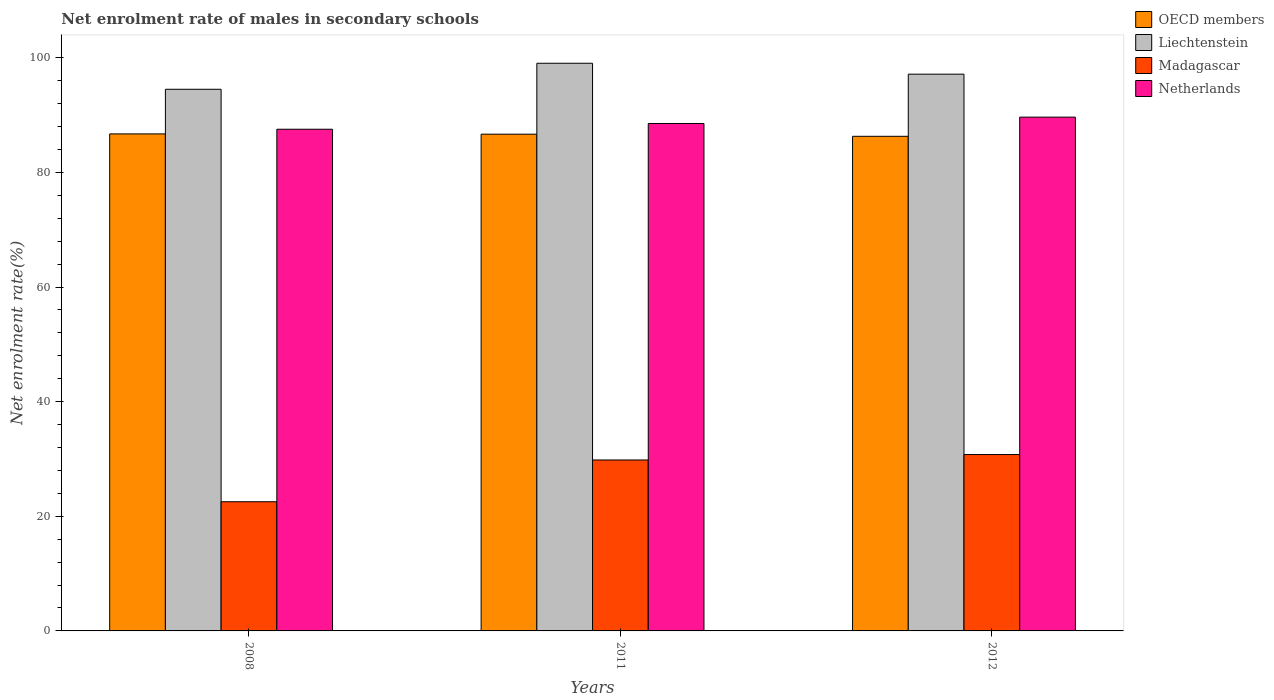How many different coloured bars are there?
Your answer should be very brief. 4. How many groups of bars are there?
Your answer should be very brief. 3. Are the number of bars per tick equal to the number of legend labels?
Provide a short and direct response. Yes. How many bars are there on the 3rd tick from the left?
Offer a terse response. 4. What is the label of the 2nd group of bars from the left?
Offer a terse response. 2011. What is the net enrolment rate of males in secondary schools in Liechtenstein in 2011?
Provide a succinct answer. 99.04. Across all years, what is the maximum net enrolment rate of males in secondary schools in OECD members?
Provide a succinct answer. 86.72. Across all years, what is the minimum net enrolment rate of males in secondary schools in Netherlands?
Provide a short and direct response. 87.53. In which year was the net enrolment rate of males in secondary schools in Netherlands minimum?
Provide a succinct answer. 2008. What is the total net enrolment rate of males in secondary schools in Netherlands in the graph?
Make the answer very short. 265.7. What is the difference between the net enrolment rate of males in secondary schools in OECD members in 2008 and that in 2011?
Make the answer very short. 0.05. What is the difference between the net enrolment rate of males in secondary schools in Liechtenstein in 2008 and the net enrolment rate of males in secondary schools in OECD members in 2012?
Offer a very short reply. 8.21. What is the average net enrolment rate of males in secondary schools in Netherlands per year?
Keep it short and to the point. 88.57. In the year 2011, what is the difference between the net enrolment rate of males in secondary schools in Netherlands and net enrolment rate of males in secondary schools in OECD members?
Provide a succinct answer. 1.86. What is the ratio of the net enrolment rate of males in secondary schools in Liechtenstein in 2011 to that in 2012?
Keep it short and to the point. 1.02. Is the net enrolment rate of males in secondary schools in Madagascar in 2011 less than that in 2012?
Offer a very short reply. Yes. What is the difference between the highest and the second highest net enrolment rate of males in secondary schools in OECD members?
Your response must be concise. 0.05. What is the difference between the highest and the lowest net enrolment rate of males in secondary schools in Liechtenstein?
Provide a short and direct response. 4.54. What does the 3rd bar from the left in 2011 represents?
Offer a terse response. Madagascar. What does the 2nd bar from the right in 2011 represents?
Your answer should be compact. Madagascar. How many bars are there?
Your answer should be very brief. 12. Are all the bars in the graph horizontal?
Offer a very short reply. No. What is the difference between two consecutive major ticks on the Y-axis?
Make the answer very short. 20. Where does the legend appear in the graph?
Keep it short and to the point. Top right. How are the legend labels stacked?
Offer a terse response. Vertical. What is the title of the graph?
Give a very brief answer. Net enrolment rate of males in secondary schools. What is the label or title of the X-axis?
Your answer should be compact. Years. What is the label or title of the Y-axis?
Your answer should be very brief. Net enrolment rate(%). What is the Net enrolment rate(%) in OECD members in 2008?
Ensure brevity in your answer.  86.72. What is the Net enrolment rate(%) of Liechtenstein in 2008?
Provide a succinct answer. 94.5. What is the Net enrolment rate(%) of Madagascar in 2008?
Ensure brevity in your answer.  22.54. What is the Net enrolment rate(%) of Netherlands in 2008?
Give a very brief answer. 87.53. What is the Net enrolment rate(%) of OECD members in 2011?
Give a very brief answer. 86.67. What is the Net enrolment rate(%) in Liechtenstein in 2011?
Make the answer very short. 99.04. What is the Net enrolment rate(%) in Madagascar in 2011?
Your response must be concise. 29.83. What is the Net enrolment rate(%) in Netherlands in 2011?
Make the answer very short. 88.53. What is the Net enrolment rate(%) of OECD members in 2012?
Offer a terse response. 86.3. What is the Net enrolment rate(%) in Liechtenstein in 2012?
Your answer should be compact. 97.14. What is the Net enrolment rate(%) in Madagascar in 2012?
Make the answer very short. 30.78. What is the Net enrolment rate(%) of Netherlands in 2012?
Keep it short and to the point. 89.64. Across all years, what is the maximum Net enrolment rate(%) of OECD members?
Ensure brevity in your answer.  86.72. Across all years, what is the maximum Net enrolment rate(%) in Liechtenstein?
Your answer should be very brief. 99.04. Across all years, what is the maximum Net enrolment rate(%) in Madagascar?
Your answer should be compact. 30.78. Across all years, what is the maximum Net enrolment rate(%) of Netherlands?
Your answer should be very brief. 89.64. Across all years, what is the minimum Net enrolment rate(%) in OECD members?
Give a very brief answer. 86.3. Across all years, what is the minimum Net enrolment rate(%) of Liechtenstein?
Your response must be concise. 94.5. Across all years, what is the minimum Net enrolment rate(%) in Madagascar?
Give a very brief answer. 22.54. Across all years, what is the minimum Net enrolment rate(%) in Netherlands?
Ensure brevity in your answer.  87.53. What is the total Net enrolment rate(%) in OECD members in the graph?
Give a very brief answer. 259.68. What is the total Net enrolment rate(%) in Liechtenstein in the graph?
Give a very brief answer. 290.68. What is the total Net enrolment rate(%) of Madagascar in the graph?
Your answer should be very brief. 83.14. What is the total Net enrolment rate(%) in Netherlands in the graph?
Give a very brief answer. 265.7. What is the difference between the Net enrolment rate(%) of OECD members in 2008 and that in 2011?
Provide a succinct answer. 0.05. What is the difference between the Net enrolment rate(%) of Liechtenstein in 2008 and that in 2011?
Keep it short and to the point. -4.54. What is the difference between the Net enrolment rate(%) in Madagascar in 2008 and that in 2011?
Make the answer very short. -7.29. What is the difference between the Net enrolment rate(%) of Netherlands in 2008 and that in 2011?
Your answer should be compact. -1. What is the difference between the Net enrolment rate(%) of OECD members in 2008 and that in 2012?
Your response must be concise. 0.42. What is the difference between the Net enrolment rate(%) of Liechtenstein in 2008 and that in 2012?
Your response must be concise. -2.64. What is the difference between the Net enrolment rate(%) of Madagascar in 2008 and that in 2012?
Ensure brevity in your answer.  -8.24. What is the difference between the Net enrolment rate(%) in Netherlands in 2008 and that in 2012?
Provide a short and direct response. -2.11. What is the difference between the Net enrolment rate(%) in OECD members in 2011 and that in 2012?
Offer a terse response. 0.37. What is the difference between the Net enrolment rate(%) of Liechtenstein in 2011 and that in 2012?
Your answer should be very brief. 1.9. What is the difference between the Net enrolment rate(%) of Madagascar in 2011 and that in 2012?
Ensure brevity in your answer.  -0.95. What is the difference between the Net enrolment rate(%) of Netherlands in 2011 and that in 2012?
Ensure brevity in your answer.  -1.11. What is the difference between the Net enrolment rate(%) of OECD members in 2008 and the Net enrolment rate(%) of Liechtenstein in 2011?
Your answer should be compact. -12.33. What is the difference between the Net enrolment rate(%) in OECD members in 2008 and the Net enrolment rate(%) in Madagascar in 2011?
Your answer should be compact. 56.89. What is the difference between the Net enrolment rate(%) in OECD members in 2008 and the Net enrolment rate(%) in Netherlands in 2011?
Provide a short and direct response. -1.82. What is the difference between the Net enrolment rate(%) of Liechtenstein in 2008 and the Net enrolment rate(%) of Madagascar in 2011?
Your answer should be very brief. 64.68. What is the difference between the Net enrolment rate(%) of Liechtenstein in 2008 and the Net enrolment rate(%) of Netherlands in 2011?
Make the answer very short. 5.97. What is the difference between the Net enrolment rate(%) of Madagascar in 2008 and the Net enrolment rate(%) of Netherlands in 2011?
Your answer should be compact. -65.99. What is the difference between the Net enrolment rate(%) in OECD members in 2008 and the Net enrolment rate(%) in Liechtenstein in 2012?
Offer a very short reply. -10.42. What is the difference between the Net enrolment rate(%) in OECD members in 2008 and the Net enrolment rate(%) in Madagascar in 2012?
Your answer should be very brief. 55.94. What is the difference between the Net enrolment rate(%) of OECD members in 2008 and the Net enrolment rate(%) of Netherlands in 2012?
Provide a short and direct response. -2.93. What is the difference between the Net enrolment rate(%) of Liechtenstein in 2008 and the Net enrolment rate(%) of Madagascar in 2012?
Offer a terse response. 63.73. What is the difference between the Net enrolment rate(%) of Liechtenstein in 2008 and the Net enrolment rate(%) of Netherlands in 2012?
Provide a succinct answer. 4.86. What is the difference between the Net enrolment rate(%) of Madagascar in 2008 and the Net enrolment rate(%) of Netherlands in 2012?
Your answer should be very brief. -67.1. What is the difference between the Net enrolment rate(%) in OECD members in 2011 and the Net enrolment rate(%) in Liechtenstein in 2012?
Keep it short and to the point. -10.47. What is the difference between the Net enrolment rate(%) of OECD members in 2011 and the Net enrolment rate(%) of Madagascar in 2012?
Offer a terse response. 55.89. What is the difference between the Net enrolment rate(%) in OECD members in 2011 and the Net enrolment rate(%) in Netherlands in 2012?
Offer a very short reply. -2.97. What is the difference between the Net enrolment rate(%) of Liechtenstein in 2011 and the Net enrolment rate(%) of Madagascar in 2012?
Make the answer very short. 68.27. What is the difference between the Net enrolment rate(%) in Liechtenstein in 2011 and the Net enrolment rate(%) in Netherlands in 2012?
Give a very brief answer. 9.4. What is the difference between the Net enrolment rate(%) of Madagascar in 2011 and the Net enrolment rate(%) of Netherlands in 2012?
Offer a very short reply. -59.82. What is the average Net enrolment rate(%) in OECD members per year?
Offer a very short reply. 86.56. What is the average Net enrolment rate(%) of Liechtenstein per year?
Your response must be concise. 96.89. What is the average Net enrolment rate(%) in Madagascar per year?
Provide a short and direct response. 27.71. What is the average Net enrolment rate(%) in Netherlands per year?
Offer a terse response. 88.57. In the year 2008, what is the difference between the Net enrolment rate(%) in OECD members and Net enrolment rate(%) in Liechtenstein?
Your answer should be very brief. -7.79. In the year 2008, what is the difference between the Net enrolment rate(%) of OECD members and Net enrolment rate(%) of Madagascar?
Ensure brevity in your answer.  64.18. In the year 2008, what is the difference between the Net enrolment rate(%) in OECD members and Net enrolment rate(%) in Netherlands?
Keep it short and to the point. -0.81. In the year 2008, what is the difference between the Net enrolment rate(%) of Liechtenstein and Net enrolment rate(%) of Madagascar?
Offer a terse response. 71.97. In the year 2008, what is the difference between the Net enrolment rate(%) of Liechtenstein and Net enrolment rate(%) of Netherlands?
Give a very brief answer. 6.97. In the year 2008, what is the difference between the Net enrolment rate(%) of Madagascar and Net enrolment rate(%) of Netherlands?
Ensure brevity in your answer.  -64.99. In the year 2011, what is the difference between the Net enrolment rate(%) of OECD members and Net enrolment rate(%) of Liechtenstein?
Keep it short and to the point. -12.37. In the year 2011, what is the difference between the Net enrolment rate(%) of OECD members and Net enrolment rate(%) of Madagascar?
Provide a succinct answer. 56.84. In the year 2011, what is the difference between the Net enrolment rate(%) in OECD members and Net enrolment rate(%) in Netherlands?
Offer a terse response. -1.86. In the year 2011, what is the difference between the Net enrolment rate(%) in Liechtenstein and Net enrolment rate(%) in Madagascar?
Keep it short and to the point. 69.22. In the year 2011, what is the difference between the Net enrolment rate(%) in Liechtenstein and Net enrolment rate(%) in Netherlands?
Make the answer very short. 10.51. In the year 2011, what is the difference between the Net enrolment rate(%) in Madagascar and Net enrolment rate(%) in Netherlands?
Provide a short and direct response. -58.71. In the year 2012, what is the difference between the Net enrolment rate(%) in OECD members and Net enrolment rate(%) in Liechtenstein?
Provide a short and direct response. -10.84. In the year 2012, what is the difference between the Net enrolment rate(%) in OECD members and Net enrolment rate(%) in Madagascar?
Offer a very short reply. 55.52. In the year 2012, what is the difference between the Net enrolment rate(%) of OECD members and Net enrolment rate(%) of Netherlands?
Provide a short and direct response. -3.35. In the year 2012, what is the difference between the Net enrolment rate(%) in Liechtenstein and Net enrolment rate(%) in Madagascar?
Your response must be concise. 66.36. In the year 2012, what is the difference between the Net enrolment rate(%) in Liechtenstein and Net enrolment rate(%) in Netherlands?
Make the answer very short. 7.5. In the year 2012, what is the difference between the Net enrolment rate(%) in Madagascar and Net enrolment rate(%) in Netherlands?
Provide a short and direct response. -58.87. What is the ratio of the Net enrolment rate(%) of Liechtenstein in 2008 to that in 2011?
Keep it short and to the point. 0.95. What is the ratio of the Net enrolment rate(%) of Madagascar in 2008 to that in 2011?
Your answer should be very brief. 0.76. What is the ratio of the Net enrolment rate(%) in Netherlands in 2008 to that in 2011?
Your answer should be very brief. 0.99. What is the ratio of the Net enrolment rate(%) in OECD members in 2008 to that in 2012?
Keep it short and to the point. 1. What is the ratio of the Net enrolment rate(%) of Liechtenstein in 2008 to that in 2012?
Provide a short and direct response. 0.97. What is the ratio of the Net enrolment rate(%) in Madagascar in 2008 to that in 2012?
Your response must be concise. 0.73. What is the ratio of the Net enrolment rate(%) in Netherlands in 2008 to that in 2012?
Keep it short and to the point. 0.98. What is the ratio of the Net enrolment rate(%) in OECD members in 2011 to that in 2012?
Ensure brevity in your answer.  1. What is the ratio of the Net enrolment rate(%) in Liechtenstein in 2011 to that in 2012?
Offer a very short reply. 1.02. What is the ratio of the Net enrolment rate(%) in Madagascar in 2011 to that in 2012?
Offer a terse response. 0.97. What is the ratio of the Net enrolment rate(%) in Netherlands in 2011 to that in 2012?
Provide a succinct answer. 0.99. What is the difference between the highest and the second highest Net enrolment rate(%) in OECD members?
Your response must be concise. 0.05. What is the difference between the highest and the second highest Net enrolment rate(%) of Liechtenstein?
Provide a succinct answer. 1.9. What is the difference between the highest and the second highest Net enrolment rate(%) in Madagascar?
Provide a succinct answer. 0.95. What is the difference between the highest and the second highest Net enrolment rate(%) in Netherlands?
Make the answer very short. 1.11. What is the difference between the highest and the lowest Net enrolment rate(%) of OECD members?
Your answer should be compact. 0.42. What is the difference between the highest and the lowest Net enrolment rate(%) of Liechtenstein?
Provide a short and direct response. 4.54. What is the difference between the highest and the lowest Net enrolment rate(%) of Madagascar?
Keep it short and to the point. 8.24. What is the difference between the highest and the lowest Net enrolment rate(%) in Netherlands?
Your answer should be very brief. 2.11. 